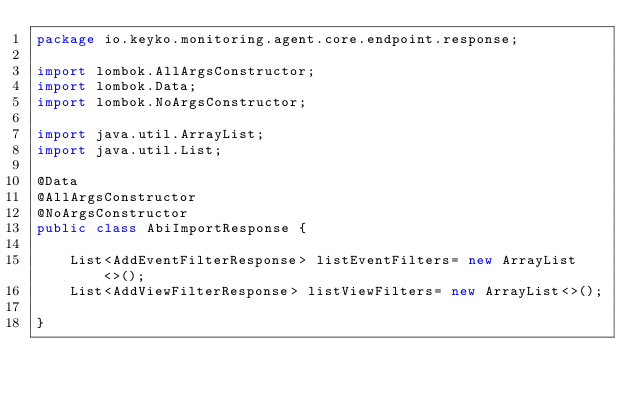Convert code to text. <code><loc_0><loc_0><loc_500><loc_500><_Java_>package io.keyko.monitoring.agent.core.endpoint.response;

import lombok.AllArgsConstructor;
import lombok.Data;
import lombok.NoArgsConstructor;

import java.util.ArrayList;
import java.util.List;

@Data
@AllArgsConstructor
@NoArgsConstructor
public class AbiImportResponse {

    List<AddEventFilterResponse> listEventFilters= new ArrayList<>();
    List<AddViewFilterResponse> listViewFilters= new ArrayList<>();

}
</code> 